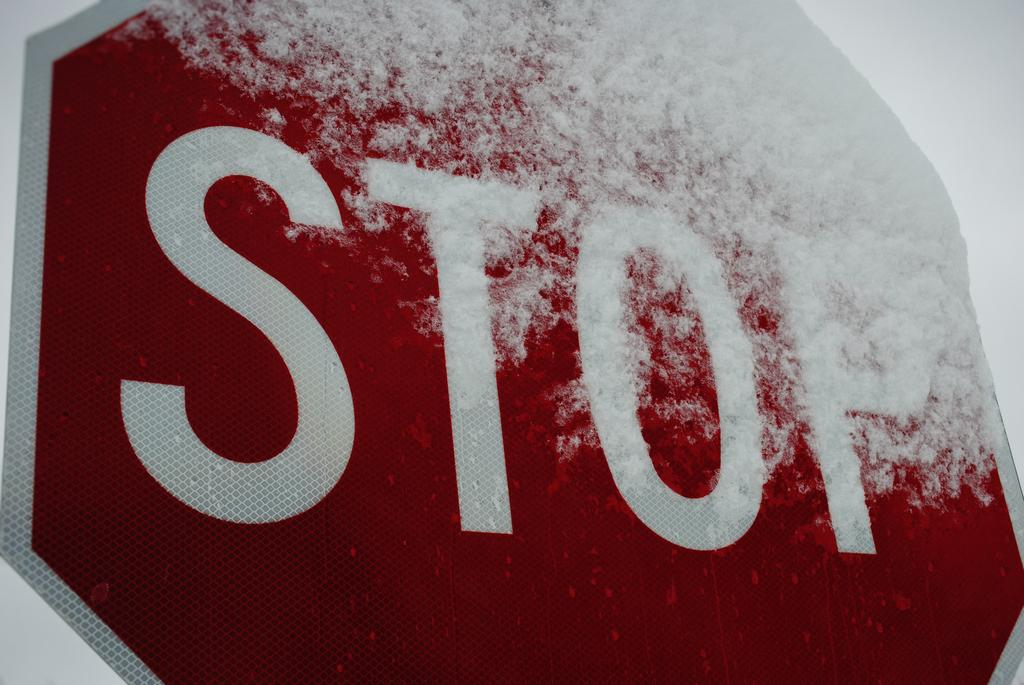<image>
Provide a brief description of the given image. a stop sign covered with some snow on the right side 